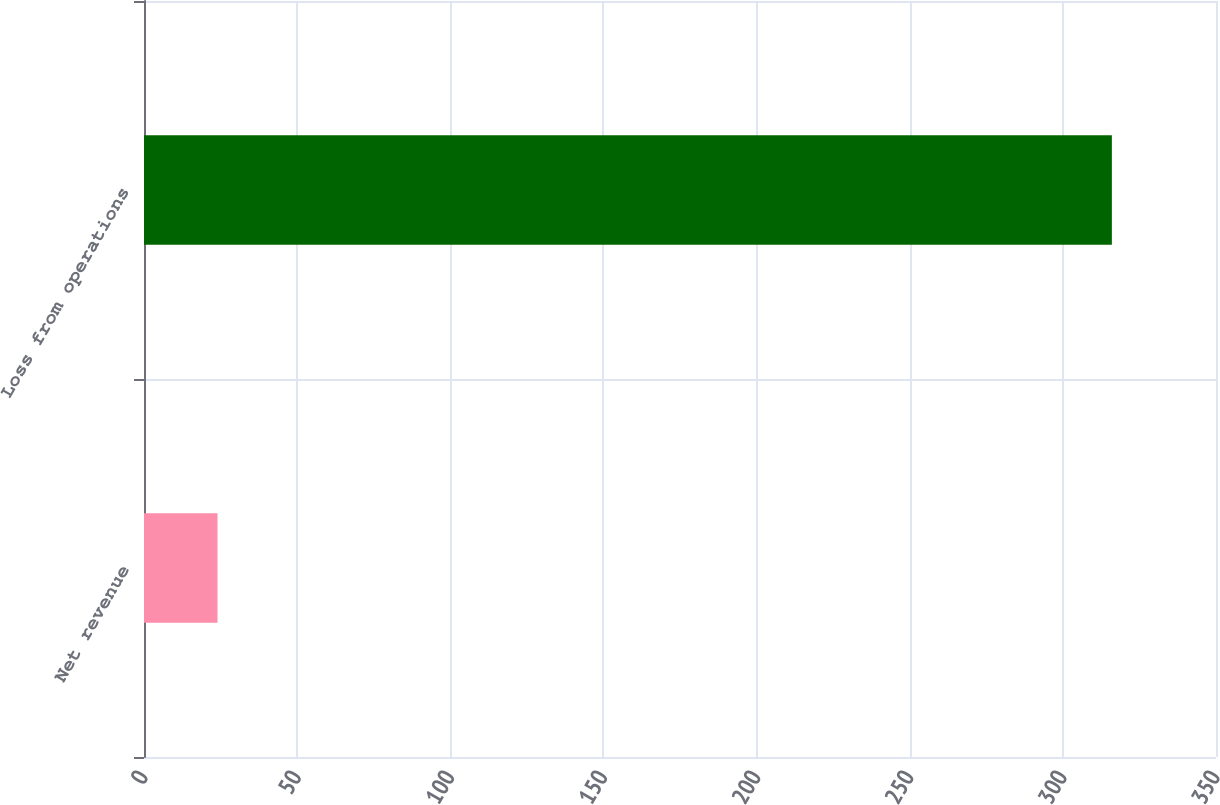Convert chart. <chart><loc_0><loc_0><loc_500><loc_500><bar_chart><fcel>Net revenue<fcel>Loss from operations<nl><fcel>24<fcel>316<nl></chart> 